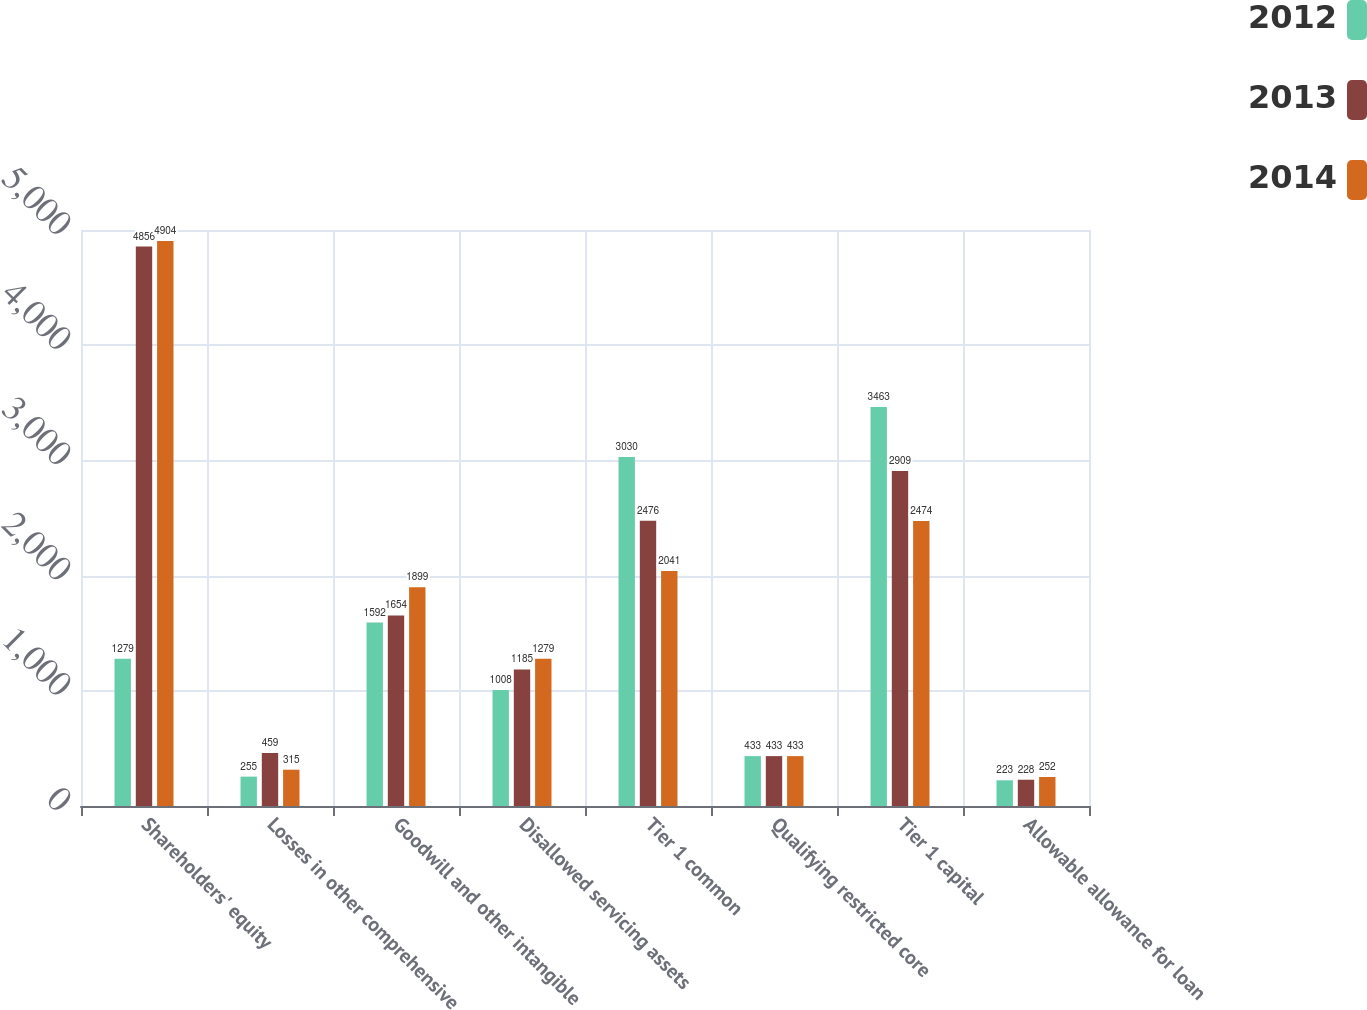Convert chart to OTSL. <chart><loc_0><loc_0><loc_500><loc_500><stacked_bar_chart><ecel><fcel>Shareholders' equity<fcel>Losses in other comprehensive<fcel>Goodwill and other intangible<fcel>Disallowed servicing assets<fcel>Tier 1 common<fcel>Qualifying restricted core<fcel>Tier 1 capital<fcel>Allowable allowance for loan<nl><fcel>2012<fcel>1279<fcel>255<fcel>1592<fcel>1008<fcel>3030<fcel>433<fcel>3463<fcel>223<nl><fcel>2013<fcel>4856<fcel>459<fcel>1654<fcel>1185<fcel>2476<fcel>433<fcel>2909<fcel>228<nl><fcel>2014<fcel>4904<fcel>315<fcel>1899<fcel>1279<fcel>2041<fcel>433<fcel>2474<fcel>252<nl></chart> 